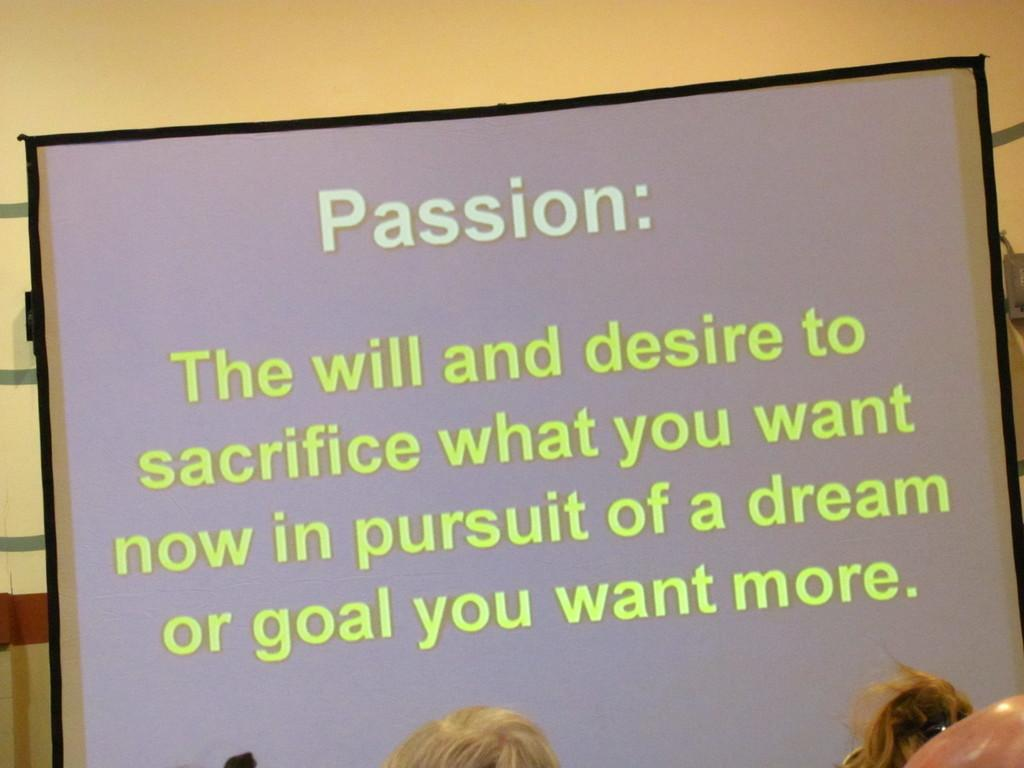What is the main object in the image? There is a projector screen in the image. Where is the projector screen located? The projector screen is placed near a wall. Can you describe any other elements in the image? A woman's head and hair are visible at the bottom of the image. What advertisement is being displayed on the projector screen? There is no advertisement visible on the projector screen in the image. What statement is the woman making in the image? The image does not show the woman making any statement; only her head and hair are visible. 